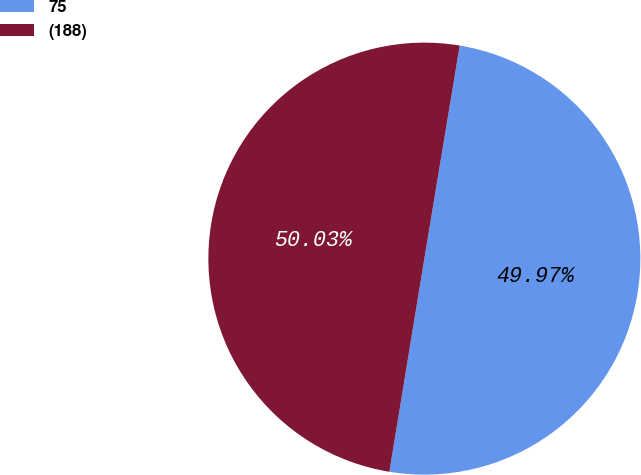<chart> <loc_0><loc_0><loc_500><loc_500><pie_chart><fcel>75<fcel>(188)<nl><fcel>49.97%<fcel>50.03%<nl></chart> 